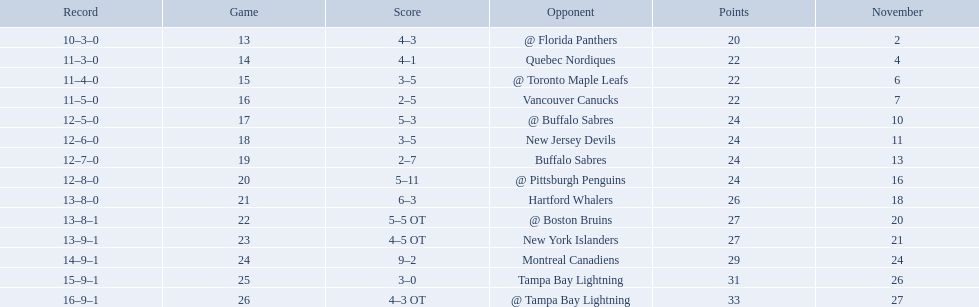What were the scores? @ Florida Panthers, 4–3, Quebec Nordiques, 4–1, @ Toronto Maple Leafs, 3–5, Vancouver Canucks, 2–5, @ Buffalo Sabres, 5–3, New Jersey Devils, 3–5, Buffalo Sabres, 2–7, @ Pittsburgh Penguins, 5–11, Hartford Whalers, 6–3, @ Boston Bruins, 5–5 OT, New York Islanders, 4–5 OT, Montreal Canadiens, 9–2, Tampa Bay Lightning, 3–0, @ Tampa Bay Lightning, 4–3 OT. What score was the closest? New York Islanders, 4–5 OT. What team had that score? New York Islanders. Who are all of the teams? @ Florida Panthers, Quebec Nordiques, @ Toronto Maple Leafs, Vancouver Canucks, @ Buffalo Sabres, New Jersey Devils, Buffalo Sabres, @ Pittsburgh Penguins, Hartford Whalers, @ Boston Bruins, New York Islanders, Montreal Canadiens, Tampa Bay Lightning. What games finished in overtime? 22, 23, 26. In game number 23, who did they face? New York Islanders. Help me parse the entirety of this table. {'header': ['Record', 'Game', 'Score', 'Opponent', 'Points', 'November'], 'rows': [['10–3–0', '13', '4–3', '@ Florida Panthers', '20', '2'], ['11–3–0', '14', '4–1', 'Quebec Nordiques', '22', '4'], ['11–4–0', '15', '3–5', '@ Toronto Maple Leafs', '22', '6'], ['11–5–0', '16', '2–5', 'Vancouver Canucks', '22', '7'], ['12–5–0', '17', '5–3', '@ Buffalo Sabres', '24', '10'], ['12–6–0', '18', '3–5', 'New Jersey Devils', '24', '11'], ['12–7–0', '19', '2–7', 'Buffalo Sabres', '24', '13'], ['12–8–0', '20', '5–11', '@ Pittsburgh Penguins', '24', '16'], ['13–8–0', '21', '6–3', 'Hartford Whalers', '26', '18'], ['13–8–1', '22', '5–5 OT', '@ Boston Bruins', '27', '20'], ['13–9–1', '23', '4–5 OT', 'New York Islanders', '27', '21'], ['14–9–1', '24', '9–2', 'Montreal Canadiens', '29', '24'], ['15–9–1', '25', '3–0', 'Tampa Bay Lightning', '31', '26'], ['16–9–1', '26', '4–3 OT', '@ Tampa Bay Lightning', '33', '27']]} 